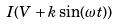Convert formula to latex. <formula><loc_0><loc_0><loc_500><loc_500>I ( V + k \sin ( \omega t ) )</formula> 